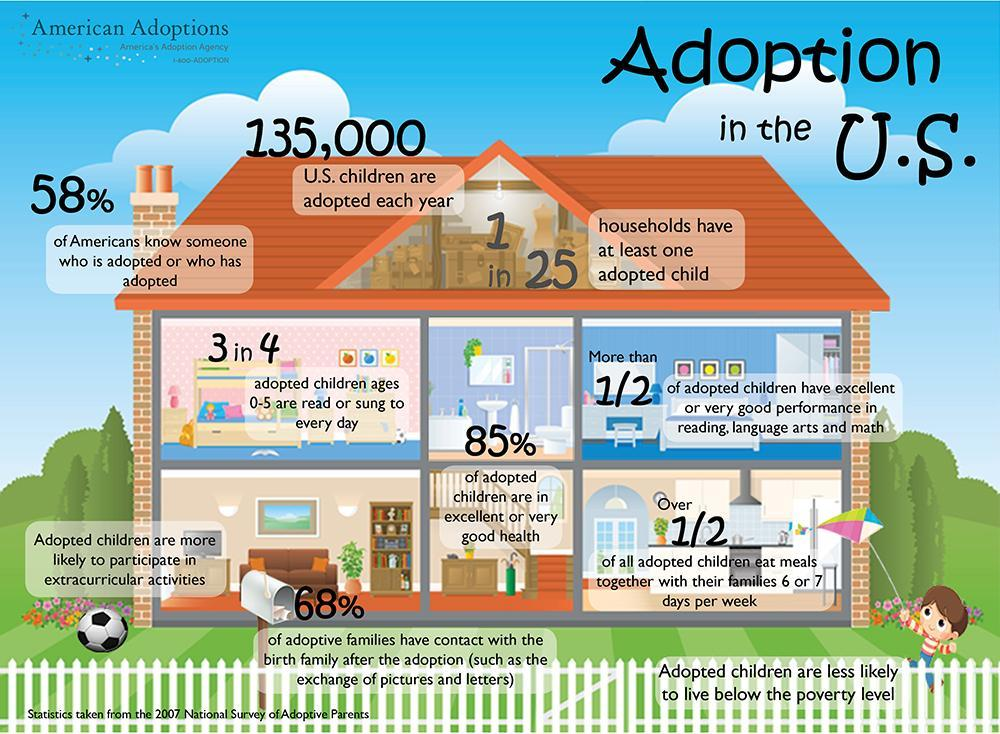How many households have atleast one adopted child?
Answer the question with a short phrase. 1 in 25 How many children are adopted each year in the US? 135,000 